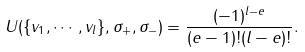<formula> <loc_0><loc_0><loc_500><loc_500>U ( \{ v _ { 1 } , \cdots , v _ { l } \} , \sigma _ { + } , \sigma _ { - } ) = \frac { ( - 1 ) ^ { l - e } } { ( e - 1 ) ! ( l - e ) ! } .</formula> 